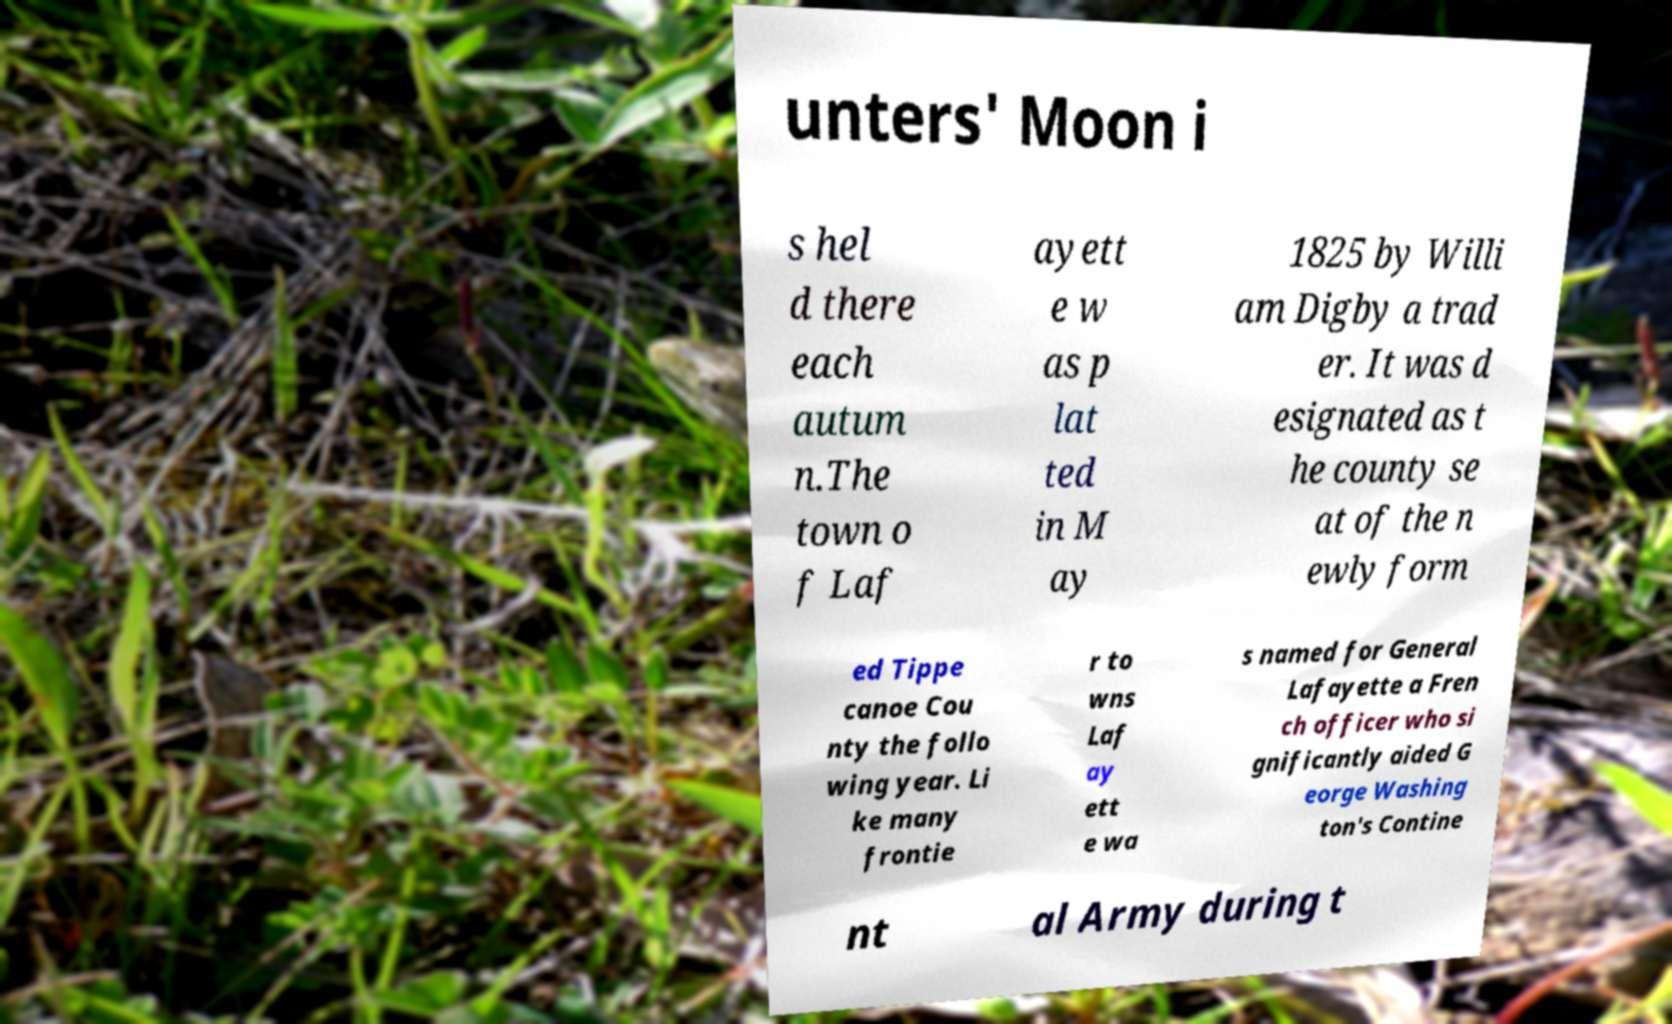Could you extract and type out the text from this image? unters' Moon i s hel d there each autum n.The town o f Laf ayett e w as p lat ted in M ay 1825 by Willi am Digby a trad er. It was d esignated as t he county se at of the n ewly form ed Tippe canoe Cou nty the follo wing year. Li ke many frontie r to wns Laf ay ett e wa s named for General Lafayette a Fren ch officer who si gnificantly aided G eorge Washing ton's Contine nt al Army during t 